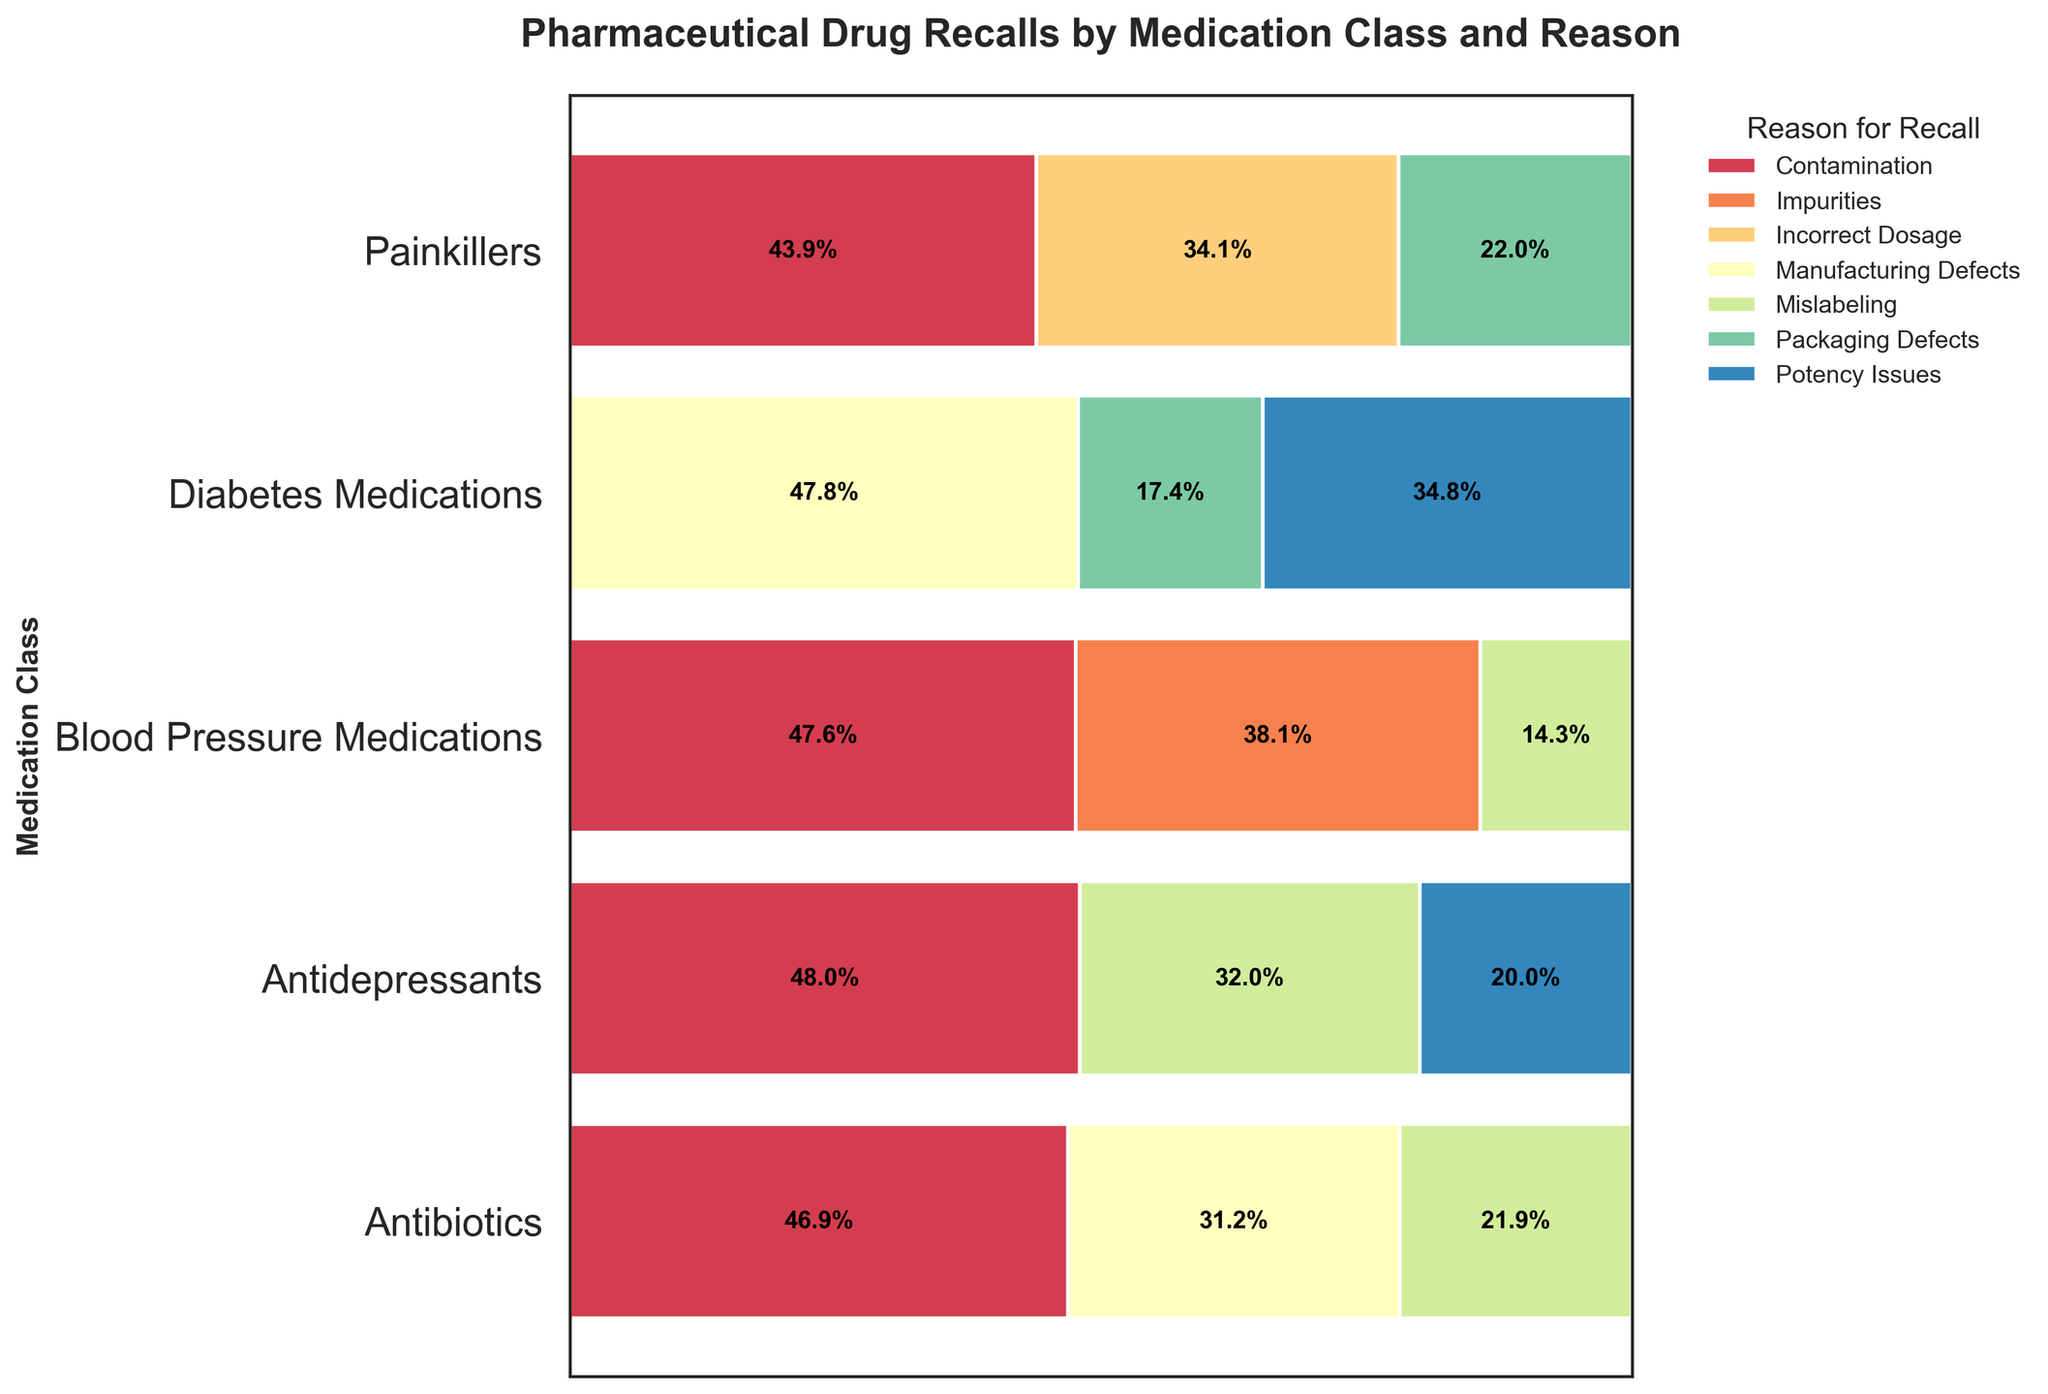What is the title of the figure? The title is always displayed at the top of the figure. From the code, we know the title is set to "Pharmaceutical Drug Recalls by Medication Class and Reason."
Answer: Pharmaceutical Drug Recalls by Medication Class and Reason Which medication class has the highest proportion of recalls due to contamination? To find this, locate the proportions related to contamination (shown in specific colors) along each bar that represents different medication classes. The segment with the greatest width indicated contamination.
Answer: Blood Pressure Medications How many distinct reasons for recall are represented in the plot? The legend on the right-hand side lists all the distinct reasons for recall, which are color-coded. Simply count the number of unique entries in the legend.
Answer: 9 What percentage of recalls for Painkillers are due to Incorrect Dosage? Locate the bar corresponding to Painkillers. Find the segment labeled Incorrect Dosage and read the percentage label within that segment.
Answer: 34.1% Which reason for recall is the least common across all medication classes? Check all the segments for each reason for recall and identify the one that is consistently small across all bars.
Answer: Packaging Defects Among the Diabetes Medications, which reasons for recall have proportions greater than 20%? Look at the bar corresponding to Diabetes Medications and identify segments with percentages greater than 20%.
Answer: Manufacturing Defects, Potency Issues Which medication class appears to have the most diversified reasons for recalls? This can be determined by identifying the bar that is divided into the most equal segments of different colors, indicating many reasons for recall with similar proportions.
Answer: Painkillers Compare the rates of recalls for Mislabeling versus Packaging Defects in Antibiotics. Which is greater and by how much? Locate the Antibiotics bar, find the segments for Mislabeling and Packaging Defects, and compare their widths. Calculate the difference in their percentages.
Answer: Mislabeling is greater by 14.6% Identify the medication class with the smallest proportion of recalls due to Potency Issues. Find all the segments labeled Potency Issues across different bars. The smallest segment among them will represent the medication class with the least proportion of Potency Issues.
Answer: Antidepressants 